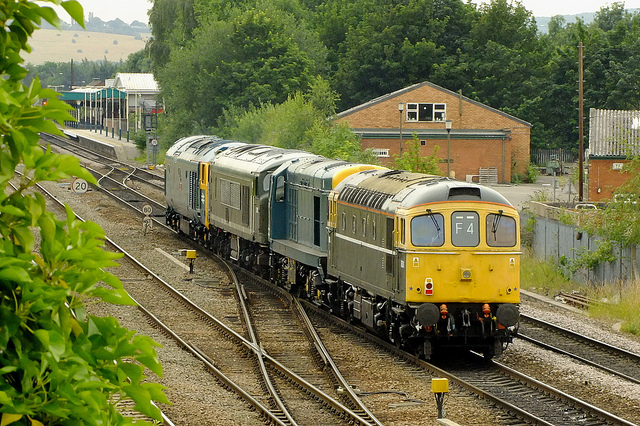Please identify all text content in this image. F 4 20 F4 